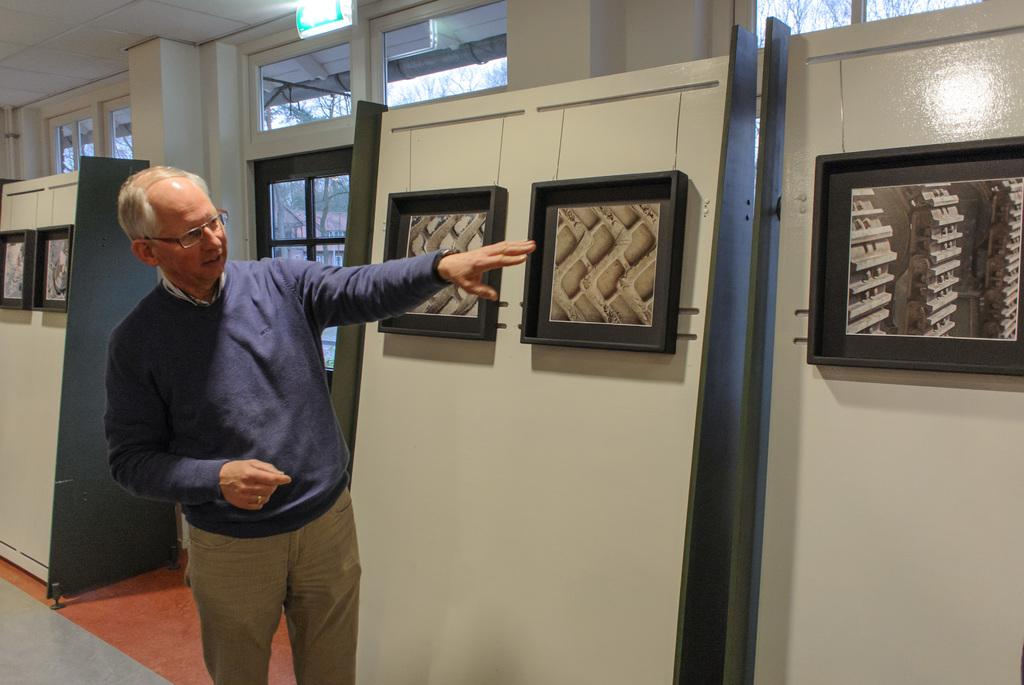What is the main subject in the image? There is a man standing in the image. What objects can be seen in the image besides the man? There are photo frames and a glass door in the image. What is the man wearing in the image? The man is wearing spectacles. What can be seen through the glass door in the image? Trees are visible through the glass door. What type of protest is happening outside the glass door in the image? There is no protest visible in the image; it only shows a man standing, photo frames, a glass door, and trees visible through the door. 